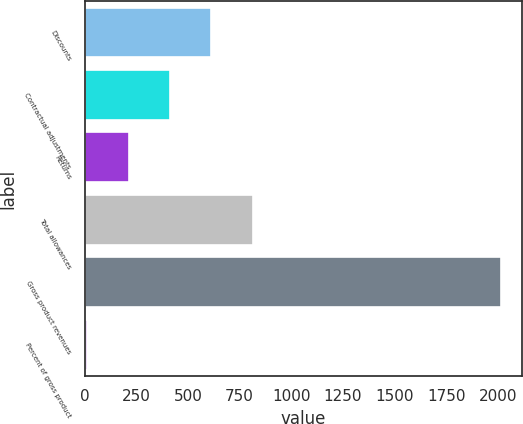Convert chart to OTSL. <chart><loc_0><loc_0><loc_500><loc_500><bar_chart><fcel>Discounts<fcel>Contractual adjustments<fcel>Returns<fcel>Total allowances<fcel>Gross product revenues<fcel>Percent of gross product<nl><fcel>613.05<fcel>412.6<fcel>212.15<fcel>813.5<fcel>2016.2<fcel>11.7<nl></chart> 